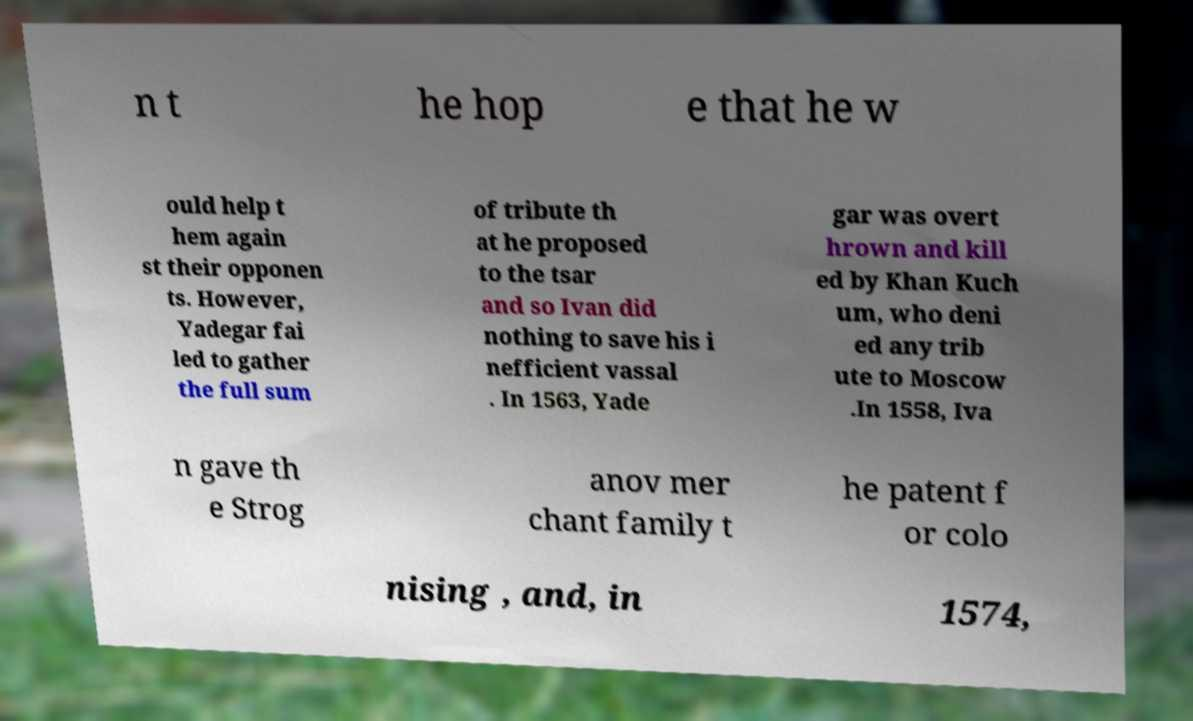Can you read and provide the text displayed in the image?This photo seems to have some interesting text. Can you extract and type it out for me? n t he hop e that he w ould help t hem again st their opponen ts. However, Yadegar fai led to gather the full sum of tribute th at he proposed to the tsar and so Ivan did nothing to save his i nefficient vassal . In 1563, Yade gar was overt hrown and kill ed by Khan Kuch um, who deni ed any trib ute to Moscow .In 1558, Iva n gave th e Strog anov mer chant family t he patent f or colo nising , and, in 1574, 